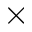<formula> <loc_0><loc_0><loc_500><loc_500>\times</formula> 